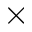<formula> <loc_0><loc_0><loc_500><loc_500>\times</formula> 